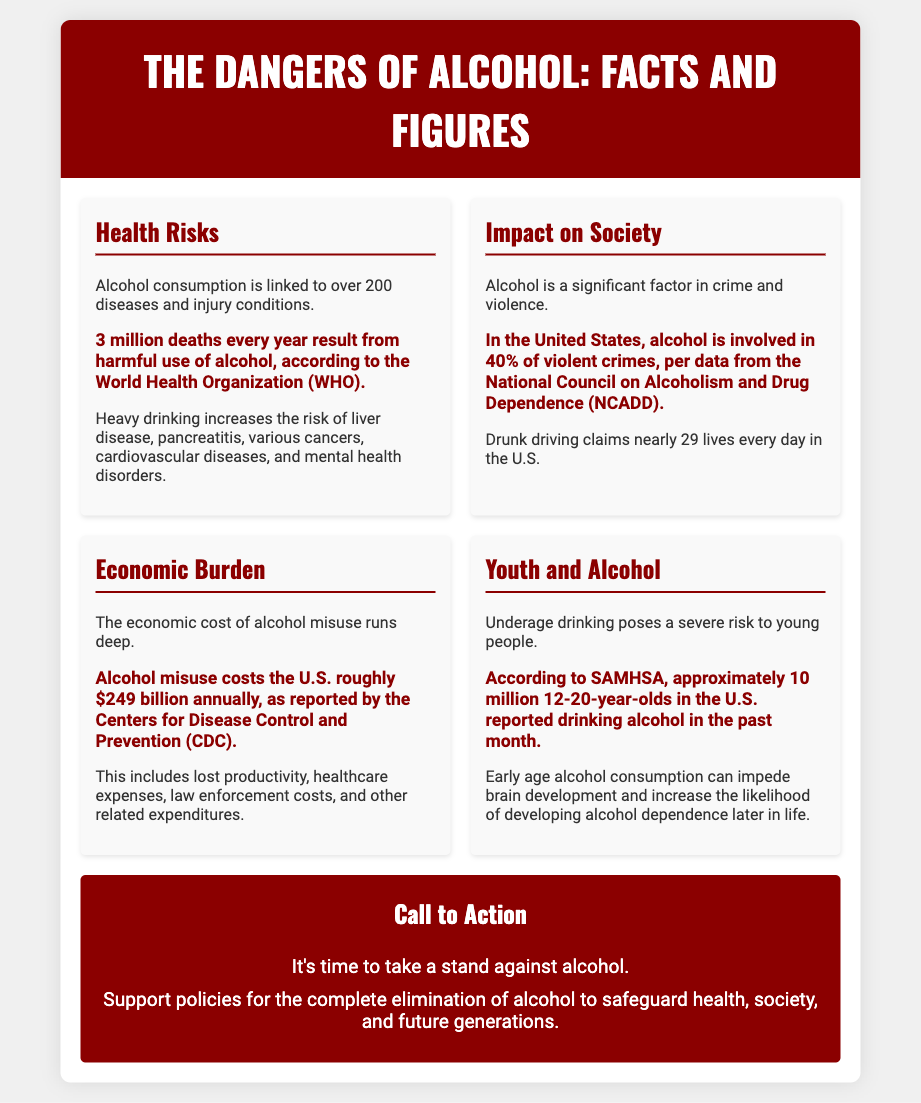what is the number of diseases linked to alcohol consumption? The document states that alcohol consumption is linked to over 200 diseases and injury conditions.
Answer: over 200 how many deaths result from harmful use of alcohol annually? According to the World Health Organization, 3 million deaths every year result from harmful use of alcohol.
Answer: 3 million what percentage of violent crimes in the U.S. involve alcohol? The National Council on Alcoholism and Drug Dependence reports that alcohol is involved in 40% of violent crimes.
Answer: 40% how many lives are claimed daily in the U.S. due to drunk driving? The document mentions that drunk driving claims nearly 29 lives every day in the U.S.
Answer: 29 what is the annual economic cost of alcohol misuse in the U.S.? The Centers for Disease Control and Prevention reports that alcohol misuse costs the U.S. roughly $249 billion annually.
Answer: $249 billion how many 12-20-year-olds reported drinking alcohol in the past month? According to SAMHSA, approximately 10 million 12-20-year-olds in the U.S. reported drinking alcohol in the past month.
Answer: 10 million what is a key call to action mentioned in the poster? The poster urges support for policies aimed at the complete elimination of alcohol to safeguard health and society.
Answer: complete elimination of alcohol which group is most affected by underage drinking? The document indicates that underage drinking poses a severe risk to young people.
Answer: young people what is a health issue heavily associated with heavy drinking? The document lists liver disease as a significant health risk associated with heavy drinking.
Answer: liver disease 